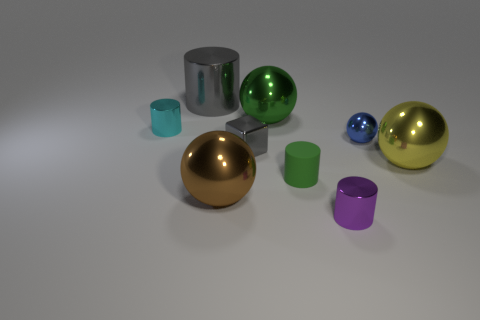Subtract all tiny metal balls. How many balls are left? 3 Subtract all cyan cylinders. How many cylinders are left? 3 Subtract all cylinders. How many objects are left? 5 Subtract 1 cubes. How many cubes are left? 0 Add 9 large brown balls. How many large brown balls are left? 10 Add 9 large gray metallic objects. How many large gray metallic objects exist? 10 Subtract 1 green cylinders. How many objects are left? 8 Subtract all red blocks. Subtract all blue balls. How many blocks are left? 1 Subtract all brown cylinders. How many yellow spheres are left? 1 Subtract all big objects. Subtract all big green shiny objects. How many objects are left? 4 